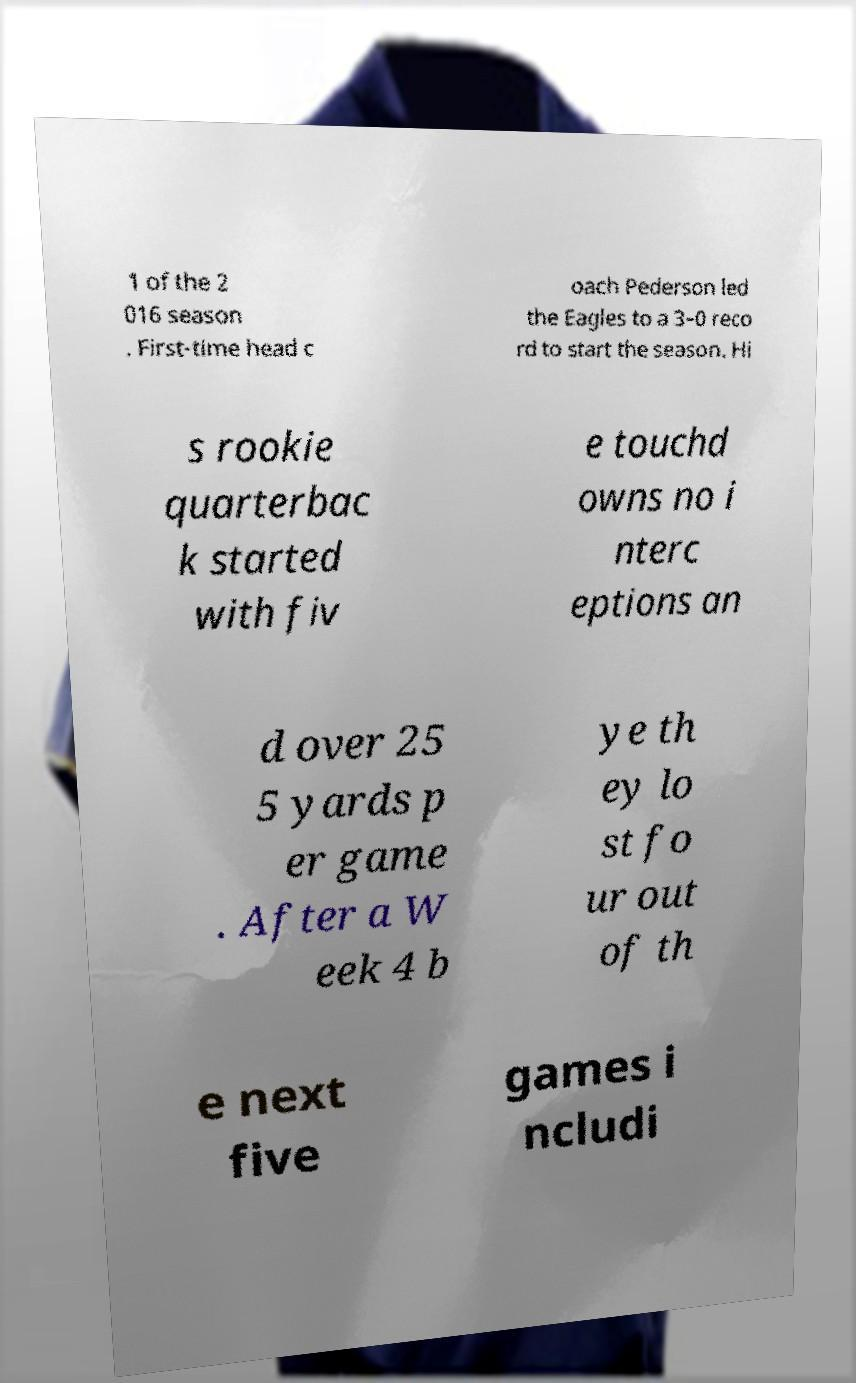Please identify and transcribe the text found in this image. 1 of the 2 016 season . First-time head c oach Pederson led the Eagles to a 3–0 reco rd to start the season. Hi s rookie quarterbac k started with fiv e touchd owns no i nterc eptions an d over 25 5 yards p er game . After a W eek 4 b ye th ey lo st fo ur out of th e next five games i ncludi 